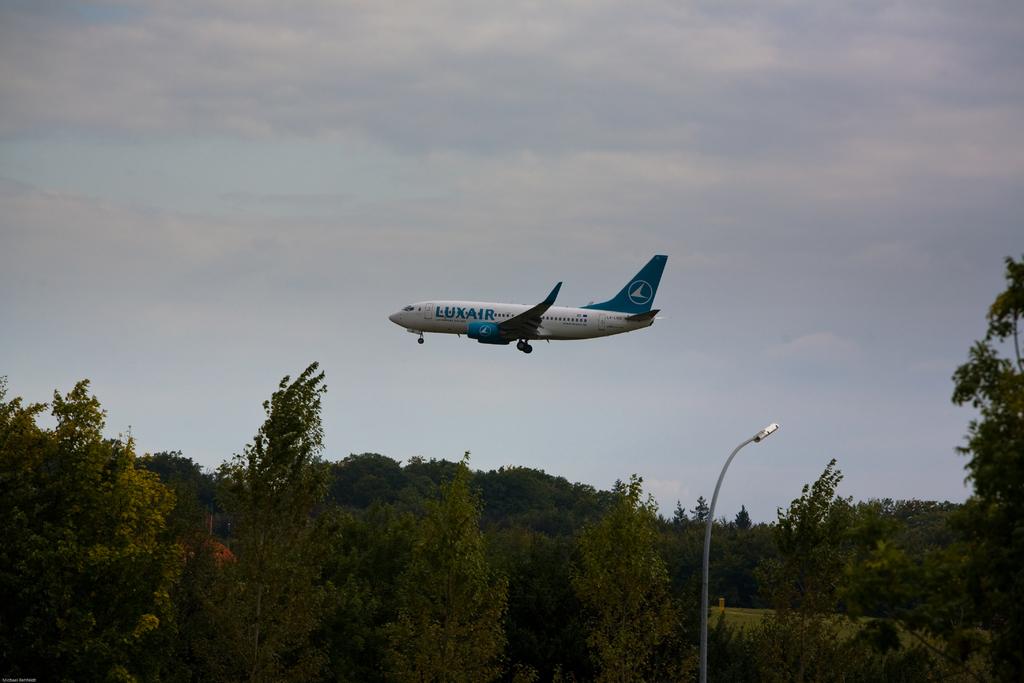What airline is this?
Offer a terse response. Luxair. 